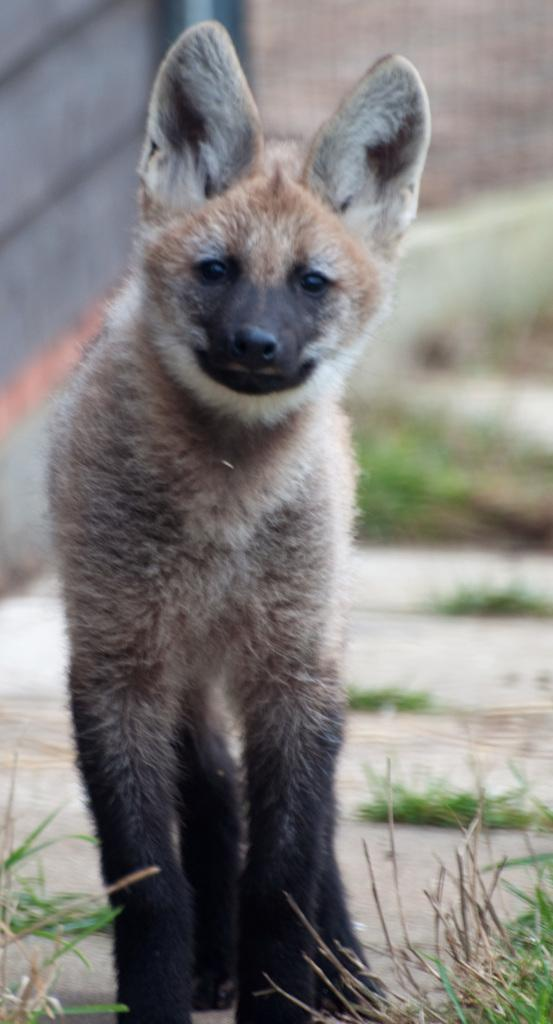What animal is standing on the path in the image? There is a hyena standing on the path in the image. What type of vegetation is visible at the bottom of the image? Grass is visible at the bottom of the image. Can you describe the background of the image? The background of the image has a blurred view, with mesh and a wall present, as well as grass. How many chairs can be seen in the image? There are no chairs present in the image. What type of animal is the zebra interacting with in the image? There is no zebra present in the image, so it cannot be interacting with any other animals. 